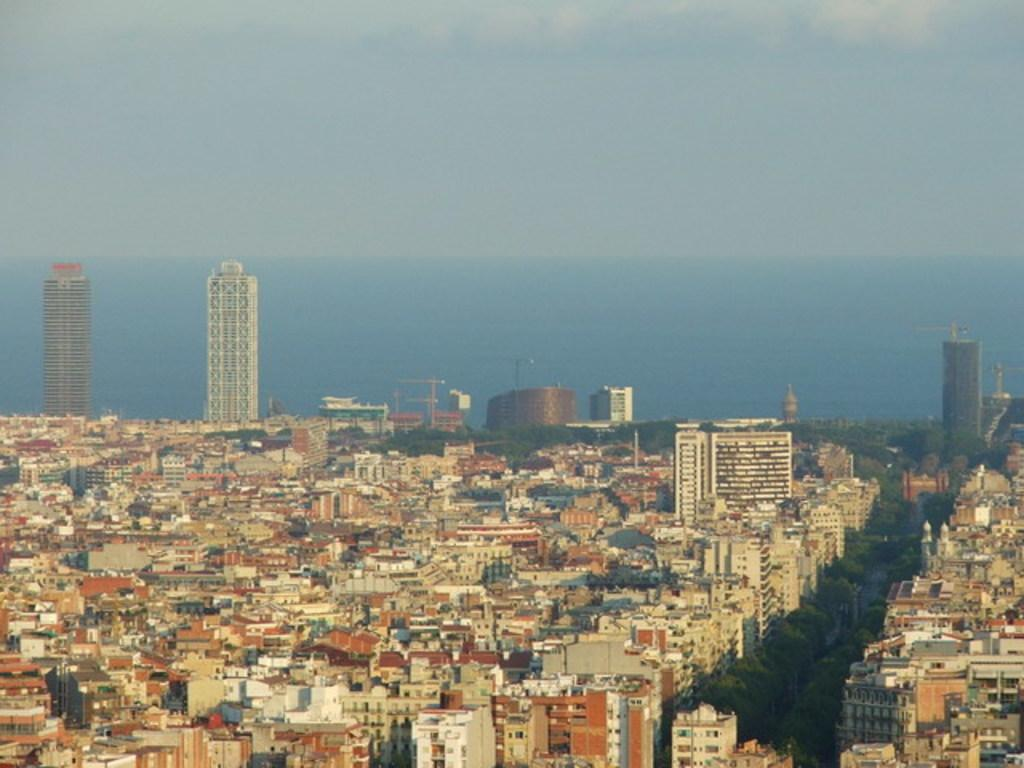What is the primary subject of the image? There are many buildings in the image. What type of natural elements can be seen in the image? There are trees and a river in the image. What is visible in the background of the image? The sky is visible in the image. How many fingers can be seen on the river in the image? There are no fingers present on the river in the image. What unit of time is depicted in the image? There is no specific unit of time depicted in the image. 